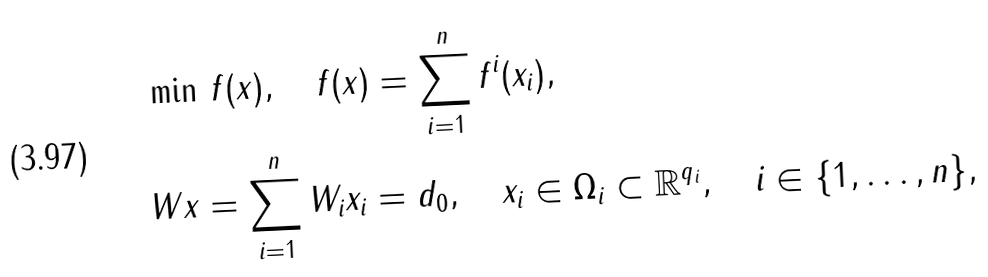<formula> <loc_0><loc_0><loc_500><loc_500>& \min \, f ( x ) , \quad f ( x ) = \sum _ { i = 1 } ^ { n } f ^ { i } ( x _ { i } ) , \\ & W x = \sum _ { i = 1 } ^ { n } W _ { i } x _ { i } = d _ { 0 } , \quad x _ { i } \in \Omega _ { i } \subset \mathbb { R } ^ { q _ { i } } , \quad i \in \{ 1 , \dots , n \} ,</formula> 